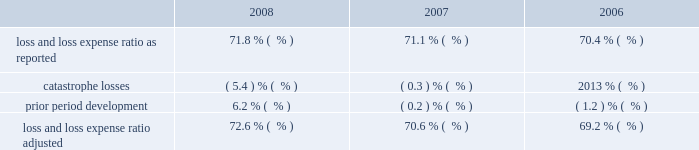Ace usa 2019s reduction in net premiums earned in 2008 was primarily driven by the decrease in financial solutions business , as the prior year included approximately $ 170 million related to a one-time assumed loss portfolio transfer program .
In addition , net premiums earned were lower in 2008 due to decreases in middle-market workers 2019 compensation business , large risk accounts and property , reflecting competitive market conditions and declining business that did not meet our selective under- writing standards .
These reductions were partially offset by growth in ace usa 2019s professional liability , specialty casualty , a&h , inland marine and foreign casualty units .
Ace usa 2019s increase in net premiums earned in 2007 , compared with 2006 , was primarily driven by assumed loss portfolio business , as well as new business in the energy unit and growth in specialty casu- alty lines .
Ace usa 2019s curtailment of middle market worker 2019s compensation business partially offset these increases .
Ace westchester 2019s reduction in net premiums earned over the last two years was primarily due to declines in casualty and inland marine business , which resulted from competitive market conditions .
This trend was partially offset by crop business growth , which benefited from generally higher commodity prices for most of 2008 and in 2007 .
Ace bermuda 2019s reduction in net premiums earned in 2008 , compared with 2007 , was a result of lower production , and the decrease in 2007 , compared with 2006 , was primarily due to the curtailment of financial solutions business .
Insurance 2013 north american 2019s loss and loss expense ratio increased in 2008 and 2007 .
The table shows the impact of catastrophe losses and prior period development on our loss and loss expense ratio for the years ended december 31 , 2008 , 2007 , and 2006. .
Insurance 2013 north american 2019s catastrophe losses were $ 298 million in 2008 , compared with $ 16 million in 2007 , and $ nil in 2006 .
Catastrophe losses in 2008 were primarily related to hurricanes gustav and ike .
Insurance 2013 north american incurred net favorable prior period development of $ 351 million in 2008 .
This compares with net adverse prior period development of $ 9 million and $ 65 million in 2007 and 2006 , respectively .
Refer to 201cprior period development 201d for more information .
The increase in the loss and loss expense ratio as adjusted in 2008 , compared with 2007 , was primarily due to changes in business mix , specifically higher premiums from the crop business , which carries a relatively high current accident year loss ratio .
In addition , the 2008 loss and loss expense ratio reflects increased loss costs , including higher incurred losses for non-catastrophe events that affected the property , marine and energy business units .
Insurance 2013 north american 2019s policy acquisition cost ratio increased in 2008 , compared with 2007 , due in part to the inclusion of ace private risk services in 2008 , which generates a higher acquisition cost ratio than our commercial p&c business .
The increase also reflects higher acquisition costs on ace westchester 2019s crop/hail business , as 2008 included more profitable results on the first quarter final settlement than in 2007 , as well as increased crop/hail production for 2008 .
The first quarter settlement in 2008 generated a higher profit share commission , which added approximately 0.8 percentage points to insurance 2013 north american 2019s 2008 policy acquisition cost ratio .
In addition , higher assumed loss portfolio transfer business in 2007 , which incurred low acquisition costs as is typical for these types of transactions , reduced the 2007 policy acquisition ratio by 0.2 percentage points .
These increases in the 2008 policy acquisition cost ratio were partially offset by improvements at ace bermuda , primarily due to increased ceding commissions .
The decrease in insurance 2013 north american 2019s 2007 policy acquisition cost ratio , compared with 2006 , was primarily related to reductions in the policy acquisition cost ratio at ace usa and ace westchester .
For ace usa , the reduction reflected higher ceding commissions as well as lower premium taxes due to reassessment of obligations for premium-based assessments and guaranty funds .
For ace westchester , the reduction in the policy acquisition cost ratio was primarily due to lower profit share commissions on crop business in 2007 , compared with insurance 2013 north american 2019s administrative expense ratio increased in 2008 , compared with 2007 , reflecting the inclusion of ace private risk services unit , which generates higher administrative expense ratios than our commercial p&c business , and the reduction in net premiums earned .
The administrative expense ratio was stable in 2007 , compared with .
In 2008 what was the ratio of the north american net favorable prior period development to the catastrophe losses? 
Computations: (351 / 298)
Answer: 1.17785. 